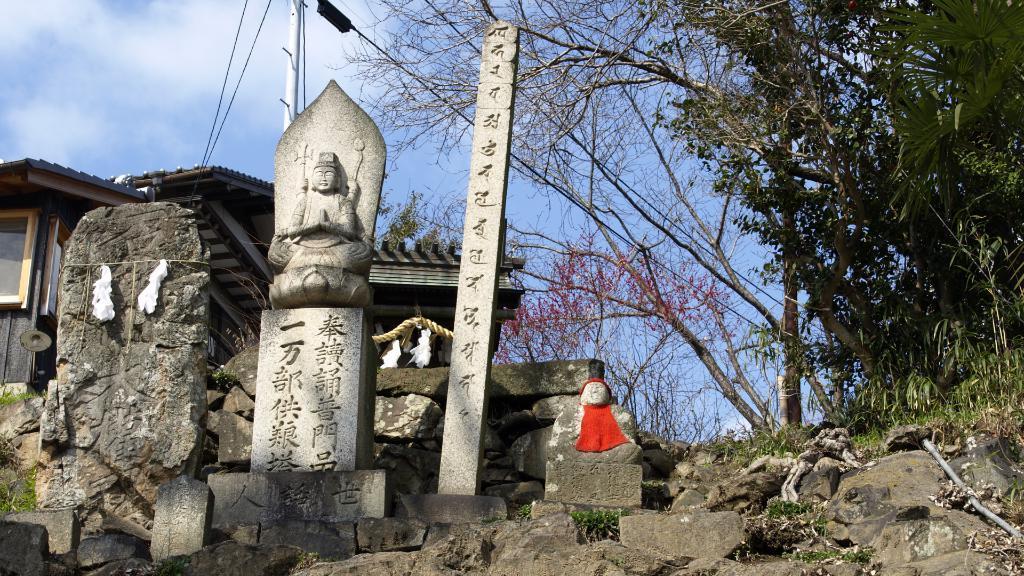Can you describe this image briefly? This picture is taken from outside of the city. In this image, on the right side, we can see some trees and plants. In the middle of the image, we can see some sculptures and a toy, on one of the sculptures, we can see a red color cloth. On the left side, we can see a rock, house, pole, electric wires. In the middle of the image, we can also see a pole. At the top, we can see a sky which is a bit cloudy, at the bottom, we can see some rocks and stones and a grass. 